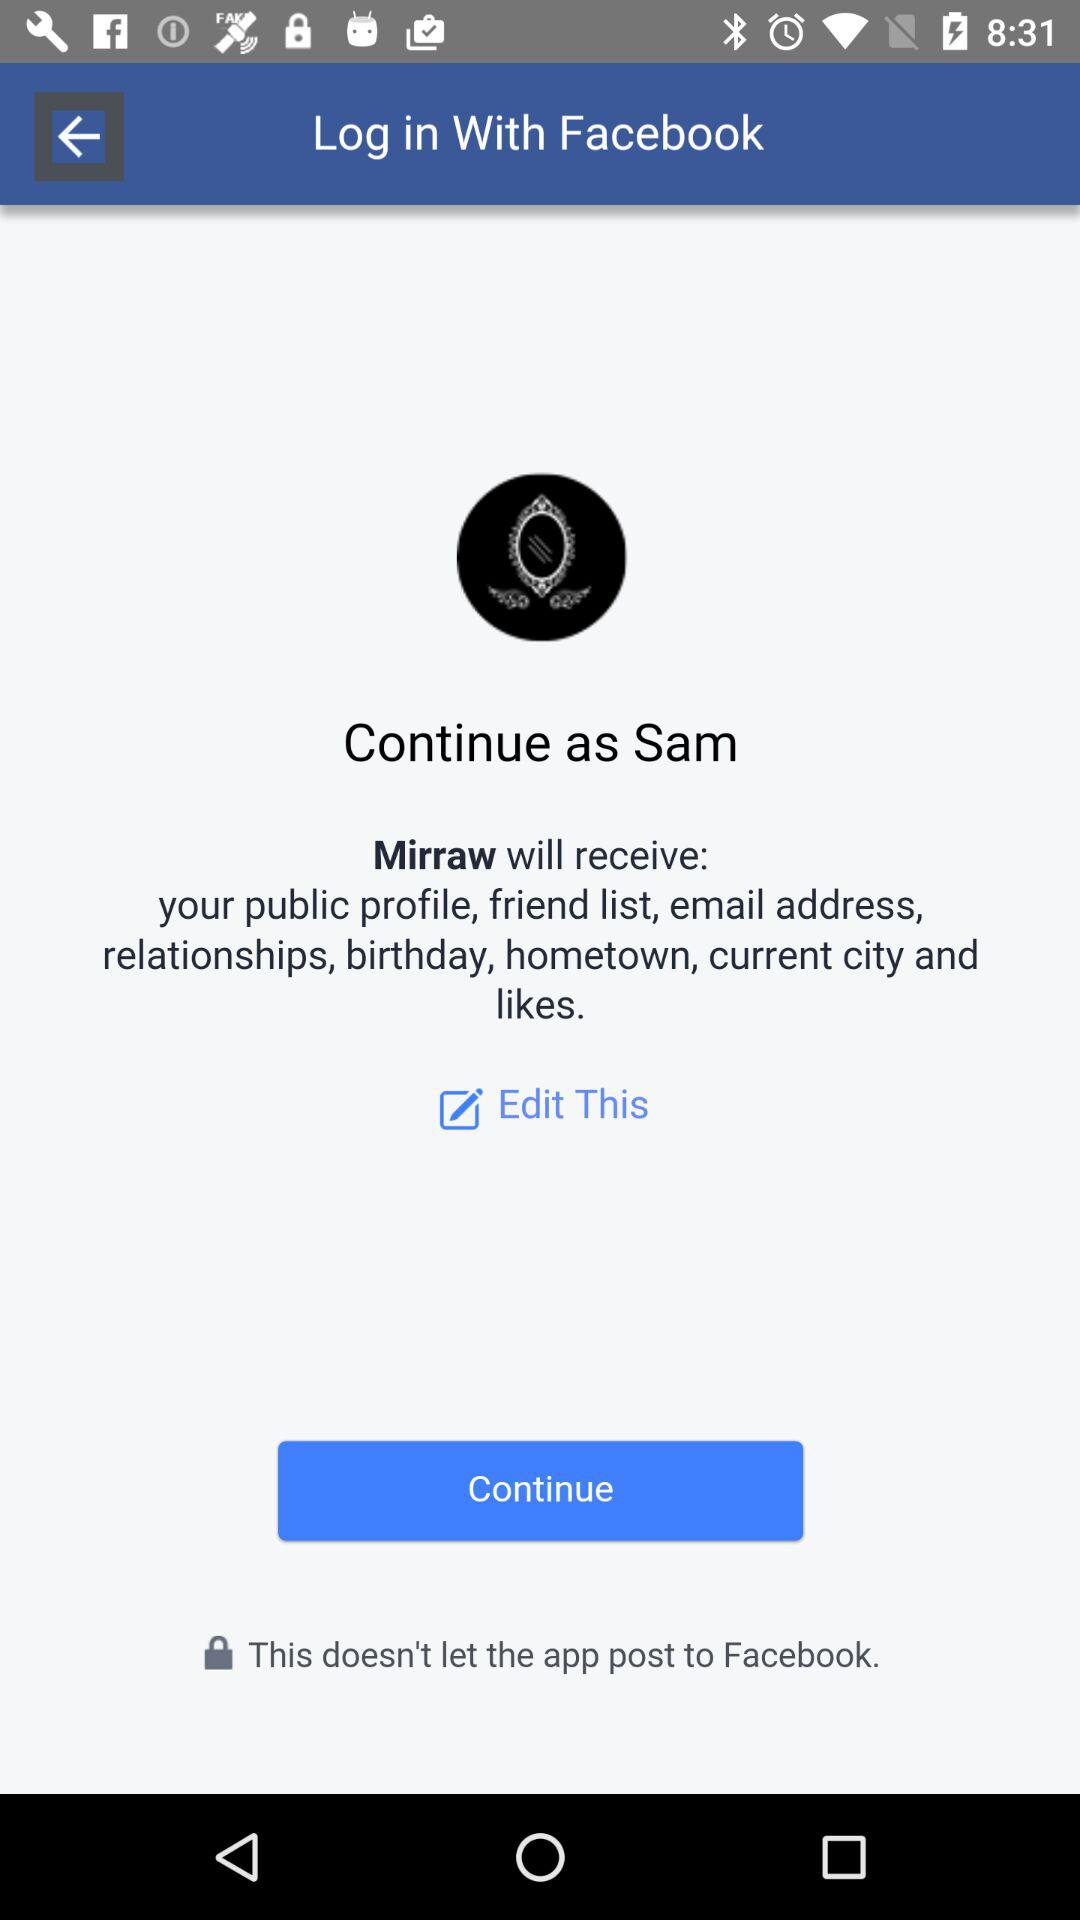What application can be used to log in? The application that can be used to log in is "Facebook". 